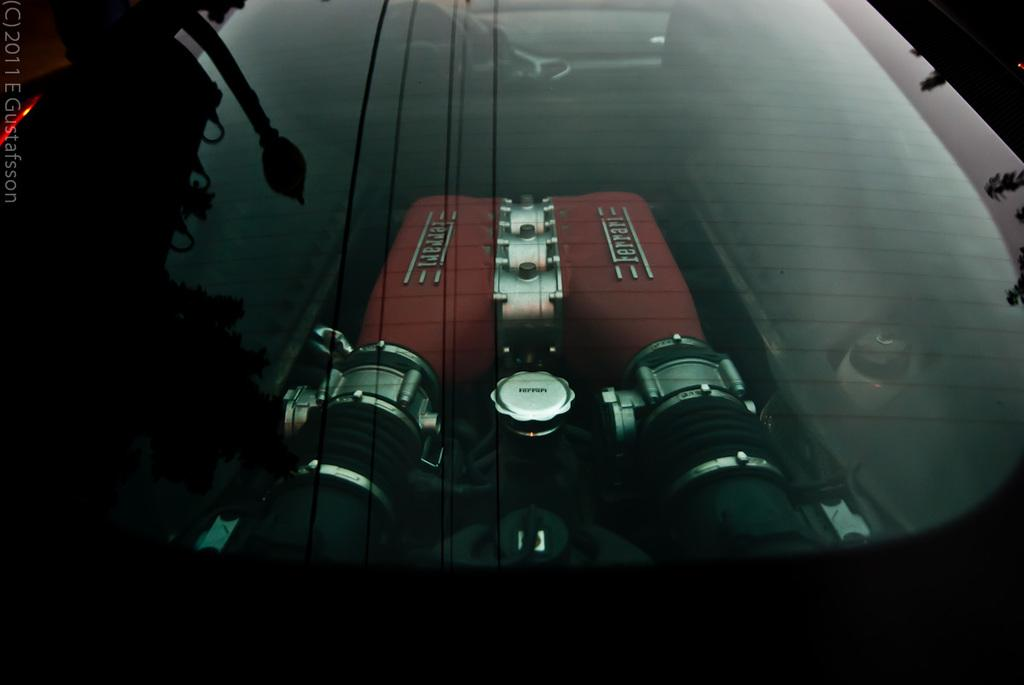What object can be seen in the image that is typically used for holding liquids? There is a glass in the image that is typically used for holding liquids. What type of device is present in the image? There is a machine in the image. Can you describe a feature that is visible on the left side of the image? A watermark is visible on the left side of the image. What type of stitch is used to create the hat in the image? There is no hat present in the image, so it is not possible to determine the type of stitch used. How is the string tied around the machine in the image? There is no string visible in the image, so it is not possible to determine how it might be tied around the machine. 